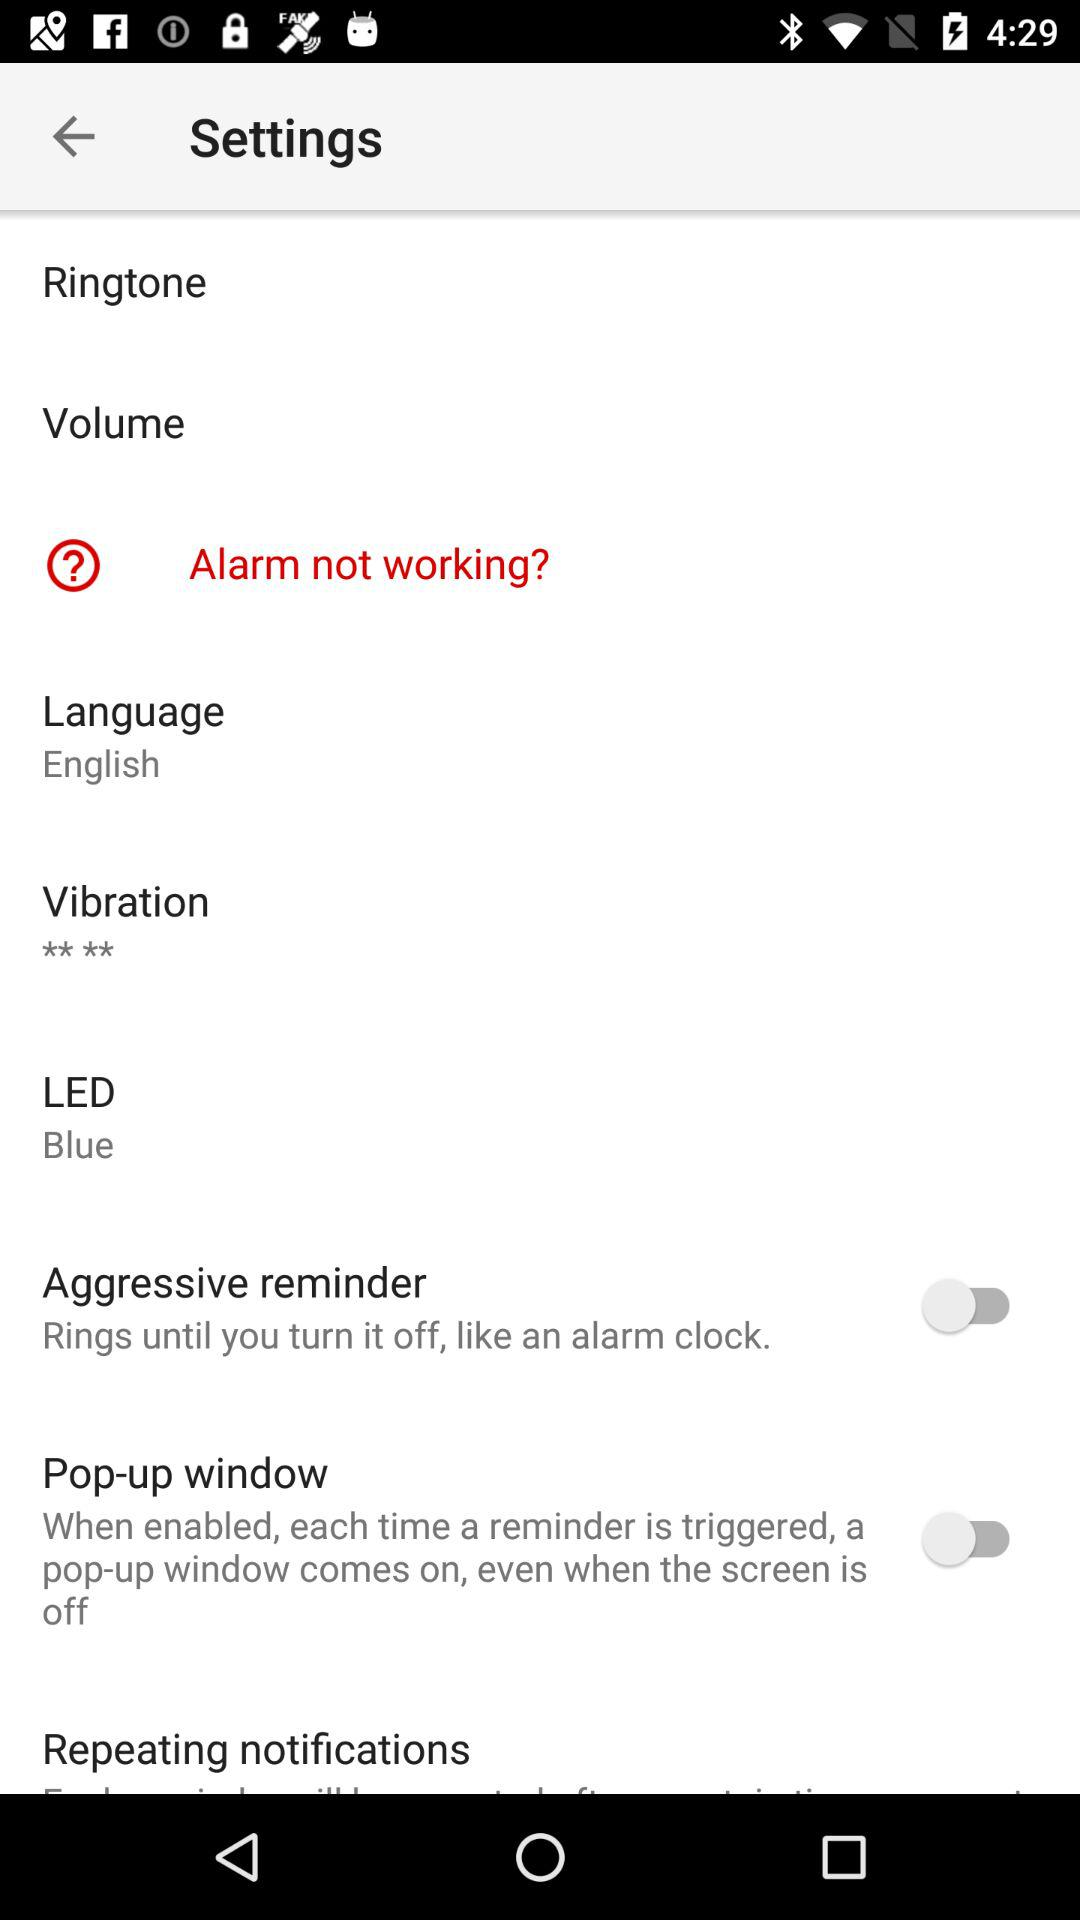What is the status of the "Pop-up window"? The status is "off". 